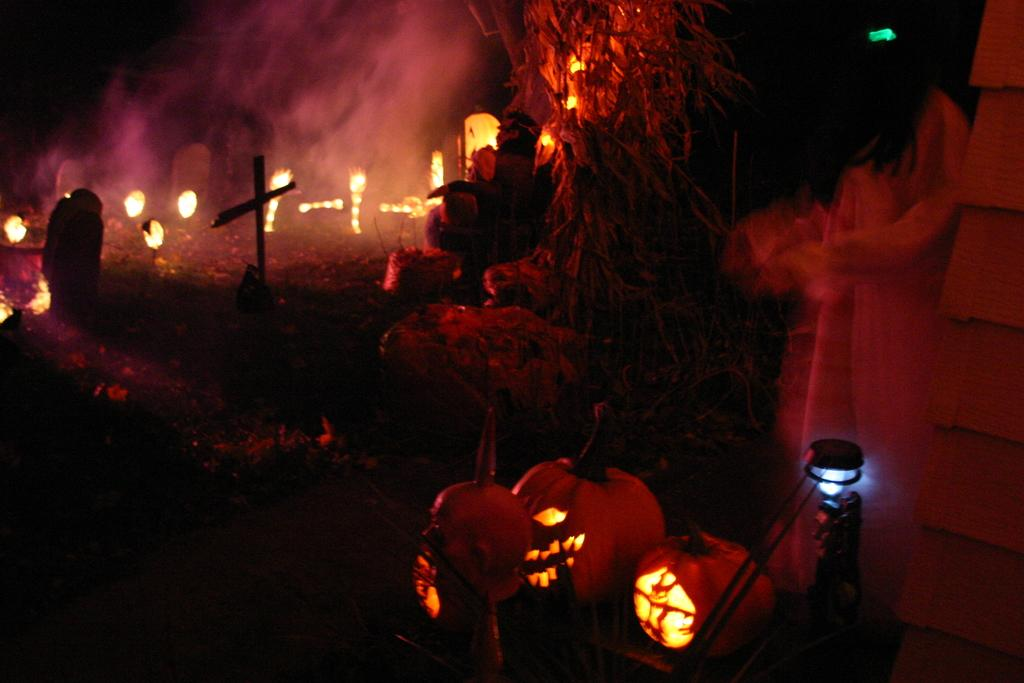What time of day was the image taken? The image was taken at night. What can be seen in the image that might provide light or warmth? There are fire pots in the image. What type of plastic material is visible on the edge of the image? There is no plastic material visible on the edge of the image. 